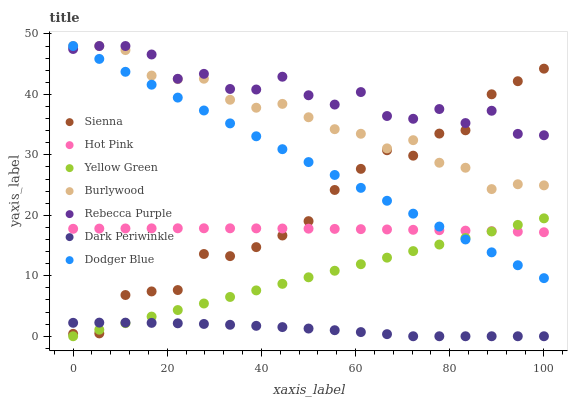Does Dark Periwinkle have the minimum area under the curve?
Answer yes or no. Yes. Does Rebecca Purple have the maximum area under the curve?
Answer yes or no. Yes. Does Burlywood have the minimum area under the curve?
Answer yes or no. No. Does Burlywood have the maximum area under the curve?
Answer yes or no. No. Is Yellow Green the smoothest?
Answer yes or no. Yes. Is Rebecca Purple the roughest?
Answer yes or no. Yes. Is Burlywood the smoothest?
Answer yes or no. No. Is Burlywood the roughest?
Answer yes or no. No. Does Yellow Green have the lowest value?
Answer yes or no. Yes. Does Burlywood have the lowest value?
Answer yes or no. No. Does Rebecca Purple have the highest value?
Answer yes or no. Yes. Does Hot Pink have the highest value?
Answer yes or no. No. Is Hot Pink less than Rebecca Purple?
Answer yes or no. Yes. Is Rebecca Purple greater than Dark Periwinkle?
Answer yes or no. Yes. Does Hot Pink intersect Sienna?
Answer yes or no. Yes. Is Hot Pink less than Sienna?
Answer yes or no. No. Is Hot Pink greater than Sienna?
Answer yes or no. No. Does Hot Pink intersect Rebecca Purple?
Answer yes or no. No. 